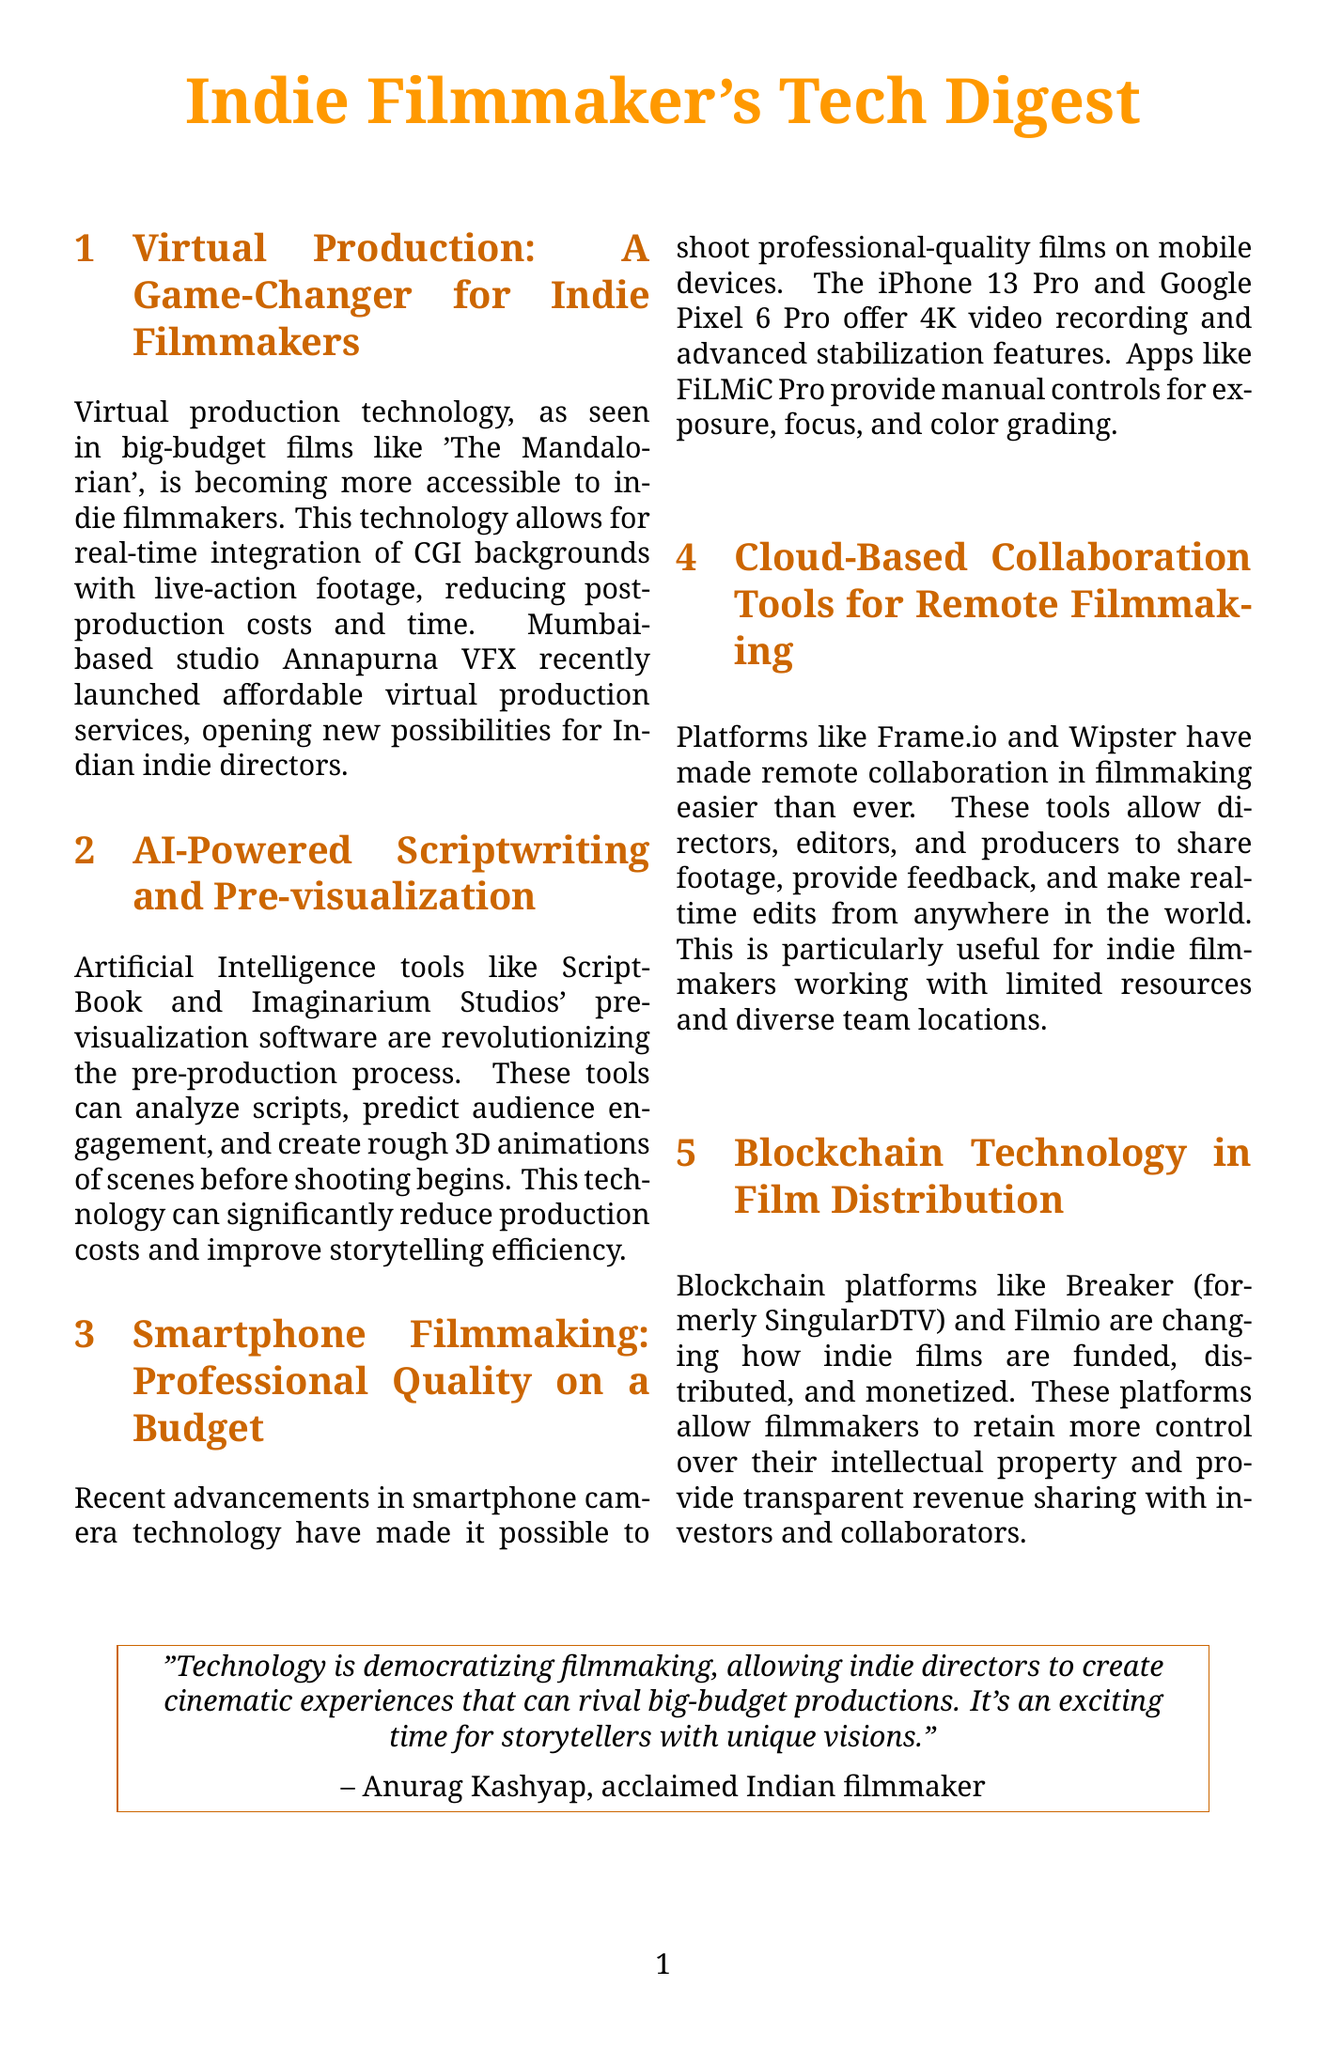What is the title of the newsletter? The title of the newsletter is formatted at the beginning of the document, indicating its focus on technology in indie filmmaking.
Answer: Indie Filmmaker's Tech Digest Which Mumbai-based studio launched affordable virtual production services? The document mentions a specific studio that recently launched these services, highlighting its location and relevance to indie filmmakers.
Answer: Annapurna VFX What technology is used in the production of 'The Mandalorian'? The document refers to a specific technology associated with a popular series, illustrating its impact on filmmaking.
Answer: Virtual production What does AI-powered scriptwriting tools analyze? The content discusses the capabilities of AI in pre-production, specifically what these tools focus on to enhance storytelling.
Answer: Scripts What is a key benefit of blockchain technology in film distribution? The document describes how blockchain impacts indie filmmakers regarding control and revenue, highlighting a major advantage.
Answer: Control over intellectual property Who is quoted in the newsletter about technology democratizing filmmaking? There is a quote included in the newsletter from an Indian filmmaker about technology's impact.
Answer: Anurag Kashyap What combination did 'Ship of Theseus' use for distribution? The case study in the newsletter illustrates a successful model employed by the film, which is crucial for indie filmmakers.
Answer: Theatrical release with online streaming Which smartphone model features 4K video recording? The newsletter lists specific smartphones that have advanced filming capabilities, mentioning them as part of modern technology.
Answer: iPhone 13 Pro How do cloud-based tools benefit indie filmmakers? The document highlights a specific advantage provided by modern collaboration platforms for filmmakers working remotely.
Answer: Remote collaboration 